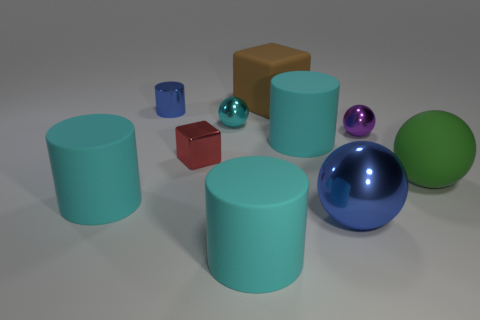There is a large cyan rubber thing that is in front of the big blue shiny thing; how many big cyan matte things are left of it?
Give a very brief answer. 1. There is a large cyan matte object in front of the blue shiny object that is in front of the green rubber object; are there any metal things right of it?
Give a very brief answer. Yes. There is another large green thing that is the same shape as the large metallic thing; what is it made of?
Offer a terse response. Rubber. Does the small blue thing have the same material as the tiny cyan thing that is behind the small red cube?
Ensure brevity in your answer.  Yes. What is the shape of the large object behind the cyan cylinder that is behind the green ball?
Your response must be concise. Cube. What number of large objects are matte cubes or purple matte objects?
Provide a short and direct response. 1. What number of blue things have the same shape as the purple thing?
Keep it short and to the point. 1. There is a small cyan thing; does it have the same shape as the large blue thing in front of the matte cube?
Your answer should be very brief. Yes. What number of blue balls are in front of the rubber sphere?
Keep it short and to the point. 1. Are there any metallic blocks of the same size as the metallic cylinder?
Offer a terse response. Yes. 